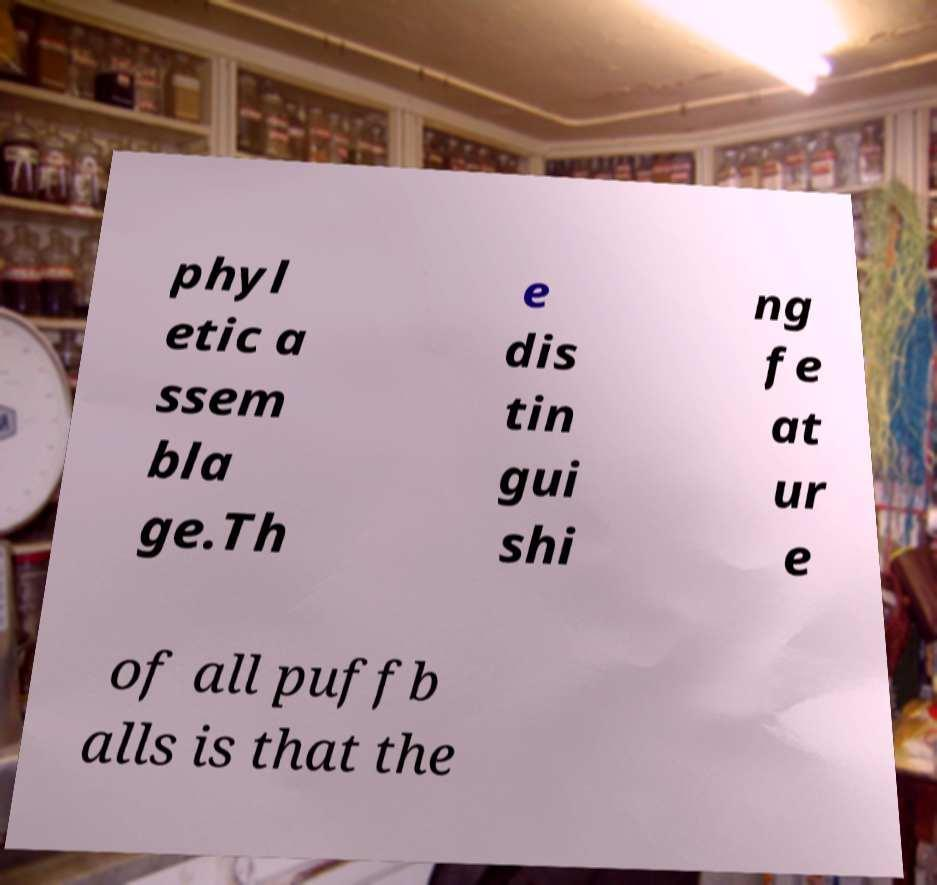Could you extract and type out the text from this image? phyl etic a ssem bla ge.Th e dis tin gui shi ng fe at ur e of all puffb alls is that the 